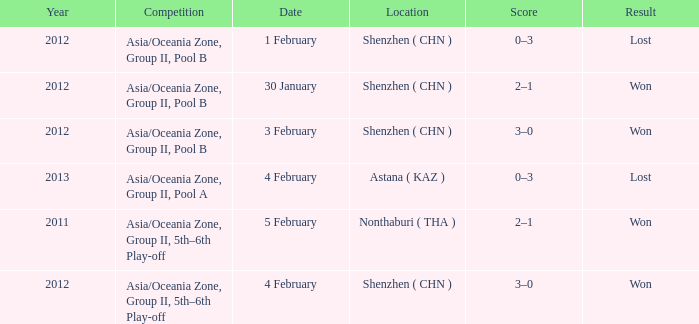What was the location for a year later than 2012? Astana ( KAZ ). Would you mind parsing the complete table? {'header': ['Year', 'Competition', 'Date', 'Location', 'Score', 'Result'], 'rows': [['2012', 'Asia/Oceania Zone, Group II, Pool B', '1 February', 'Shenzhen ( CHN )', '0–3', 'Lost'], ['2012', 'Asia/Oceania Zone, Group II, Pool B', '30 January', 'Shenzhen ( CHN )', '2–1', 'Won'], ['2012', 'Asia/Oceania Zone, Group II, Pool B', '3 February', 'Shenzhen ( CHN )', '3–0', 'Won'], ['2013', 'Asia/Oceania Zone, Group II, Pool A', '4 February', 'Astana ( KAZ )', '0–3', 'Lost'], ['2011', 'Asia/Oceania Zone, Group II, 5th–6th Play-off', '5 February', 'Nonthaburi ( THA )', '2–1', 'Won'], ['2012', 'Asia/Oceania Zone, Group II, 5th–6th Play-off', '4 February', 'Shenzhen ( CHN )', '3–0', 'Won']]} 